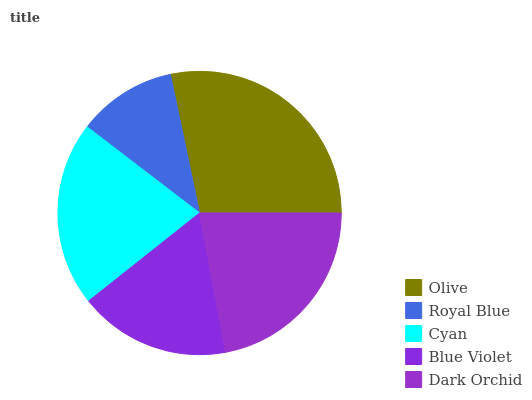Is Royal Blue the minimum?
Answer yes or no. Yes. Is Olive the maximum?
Answer yes or no. Yes. Is Cyan the minimum?
Answer yes or no. No. Is Cyan the maximum?
Answer yes or no. No. Is Cyan greater than Royal Blue?
Answer yes or no. Yes. Is Royal Blue less than Cyan?
Answer yes or no. Yes. Is Royal Blue greater than Cyan?
Answer yes or no. No. Is Cyan less than Royal Blue?
Answer yes or no. No. Is Cyan the high median?
Answer yes or no. Yes. Is Cyan the low median?
Answer yes or no. Yes. Is Olive the high median?
Answer yes or no. No. Is Royal Blue the low median?
Answer yes or no. No. 